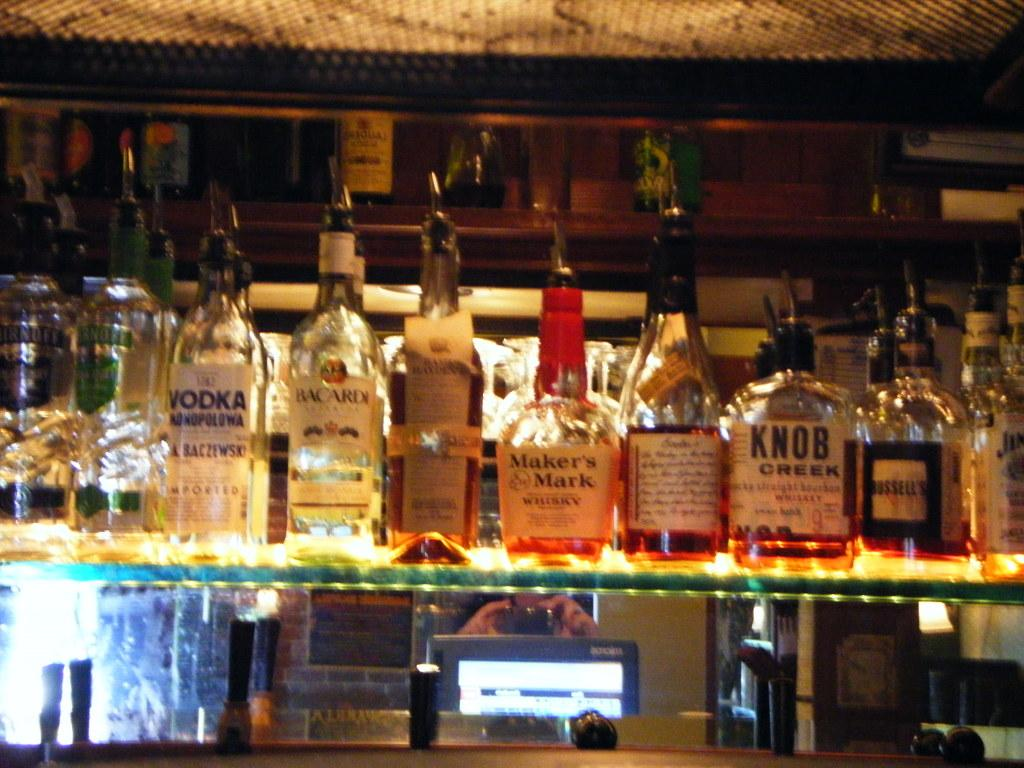<image>
Create a compact narrative representing the image presented. A bottle of Maker's Mark whiskey sits in the middle of other bottles on a shelf. 